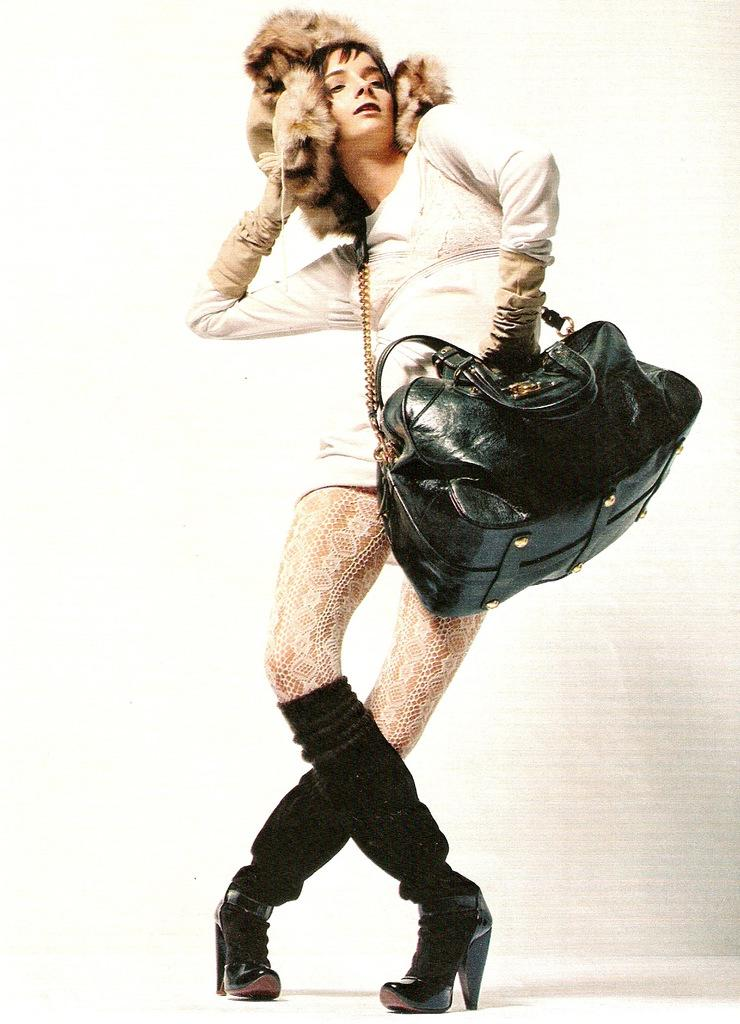What is the main subject of the image? There is a woman in the image. What is the woman holding or carrying in the image? The woman is carrying a bag. What type of wool is being used to create friction on the land in the image? There is no wool or land present in the image; it only features a woman carrying a bag. 